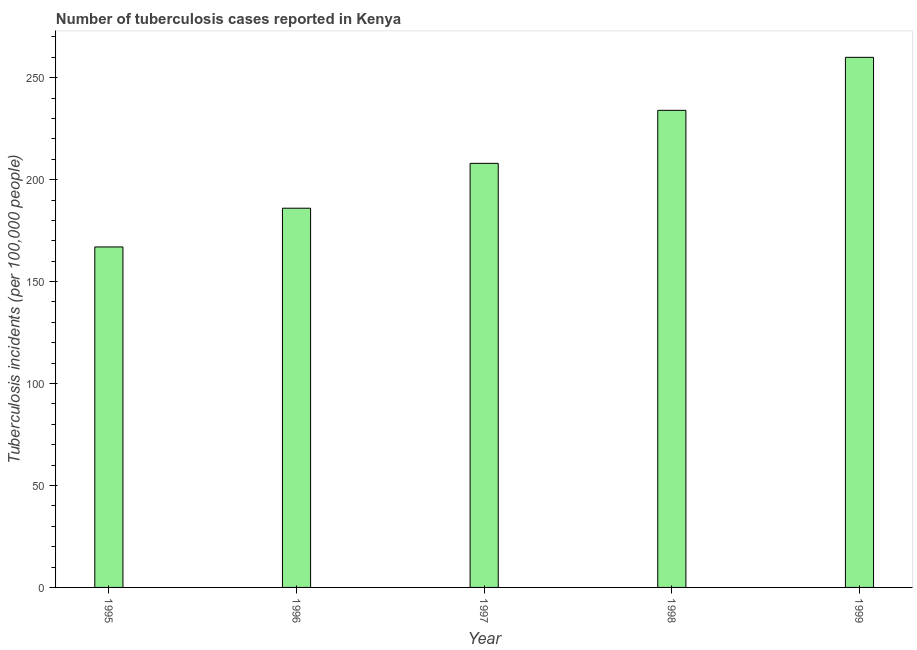Does the graph contain any zero values?
Ensure brevity in your answer.  No. What is the title of the graph?
Offer a terse response. Number of tuberculosis cases reported in Kenya. What is the label or title of the Y-axis?
Your answer should be compact. Tuberculosis incidents (per 100,0 people). What is the number of tuberculosis incidents in 1999?
Your response must be concise. 260. Across all years, what is the maximum number of tuberculosis incidents?
Provide a succinct answer. 260. Across all years, what is the minimum number of tuberculosis incidents?
Offer a terse response. 167. In which year was the number of tuberculosis incidents maximum?
Keep it short and to the point. 1999. In which year was the number of tuberculosis incidents minimum?
Offer a very short reply. 1995. What is the sum of the number of tuberculosis incidents?
Provide a succinct answer. 1055. What is the difference between the number of tuberculosis incidents in 1995 and 1997?
Offer a very short reply. -41. What is the average number of tuberculosis incidents per year?
Make the answer very short. 211. What is the median number of tuberculosis incidents?
Your answer should be very brief. 208. In how many years, is the number of tuberculosis incidents greater than 100 ?
Keep it short and to the point. 5. What is the ratio of the number of tuberculosis incidents in 1995 to that in 1997?
Ensure brevity in your answer.  0.8. Is the number of tuberculosis incidents in 1995 less than that in 1999?
Offer a terse response. Yes. Is the sum of the number of tuberculosis incidents in 1997 and 1998 greater than the maximum number of tuberculosis incidents across all years?
Ensure brevity in your answer.  Yes. What is the difference between the highest and the lowest number of tuberculosis incidents?
Offer a very short reply. 93. In how many years, is the number of tuberculosis incidents greater than the average number of tuberculosis incidents taken over all years?
Give a very brief answer. 2. How many bars are there?
Offer a very short reply. 5. What is the difference between two consecutive major ticks on the Y-axis?
Ensure brevity in your answer.  50. Are the values on the major ticks of Y-axis written in scientific E-notation?
Your answer should be very brief. No. What is the Tuberculosis incidents (per 100,000 people) in 1995?
Keep it short and to the point. 167. What is the Tuberculosis incidents (per 100,000 people) in 1996?
Make the answer very short. 186. What is the Tuberculosis incidents (per 100,000 people) of 1997?
Your answer should be very brief. 208. What is the Tuberculosis incidents (per 100,000 people) in 1998?
Offer a very short reply. 234. What is the Tuberculosis incidents (per 100,000 people) in 1999?
Give a very brief answer. 260. What is the difference between the Tuberculosis incidents (per 100,000 people) in 1995 and 1997?
Keep it short and to the point. -41. What is the difference between the Tuberculosis incidents (per 100,000 people) in 1995 and 1998?
Your response must be concise. -67. What is the difference between the Tuberculosis incidents (per 100,000 people) in 1995 and 1999?
Make the answer very short. -93. What is the difference between the Tuberculosis incidents (per 100,000 people) in 1996 and 1998?
Your answer should be very brief. -48. What is the difference between the Tuberculosis incidents (per 100,000 people) in 1996 and 1999?
Your answer should be compact. -74. What is the difference between the Tuberculosis incidents (per 100,000 people) in 1997 and 1998?
Your answer should be very brief. -26. What is the difference between the Tuberculosis incidents (per 100,000 people) in 1997 and 1999?
Your answer should be compact. -52. What is the ratio of the Tuberculosis incidents (per 100,000 people) in 1995 to that in 1996?
Keep it short and to the point. 0.9. What is the ratio of the Tuberculosis incidents (per 100,000 people) in 1995 to that in 1997?
Give a very brief answer. 0.8. What is the ratio of the Tuberculosis incidents (per 100,000 people) in 1995 to that in 1998?
Your answer should be very brief. 0.71. What is the ratio of the Tuberculosis incidents (per 100,000 people) in 1995 to that in 1999?
Give a very brief answer. 0.64. What is the ratio of the Tuberculosis incidents (per 100,000 people) in 1996 to that in 1997?
Offer a very short reply. 0.89. What is the ratio of the Tuberculosis incidents (per 100,000 people) in 1996 to that in 1998?
Provide a succinct answer. 0.8. What is the ratio of the Tuberculosis incidents (per 100,000 people) in 1996 to that in 1999?
Offer a terse response. 0.71. What is the ratio of the Tuberculosis incidents (per 100,000 people) in 1997 to that in 1998?
Ensure brevity in your answer.  0.89. What is the ratio of the Tuberculosis incidents (per 100,000 people) in 1997 to that in 1999?
Offer a very short reply. 0.8. 